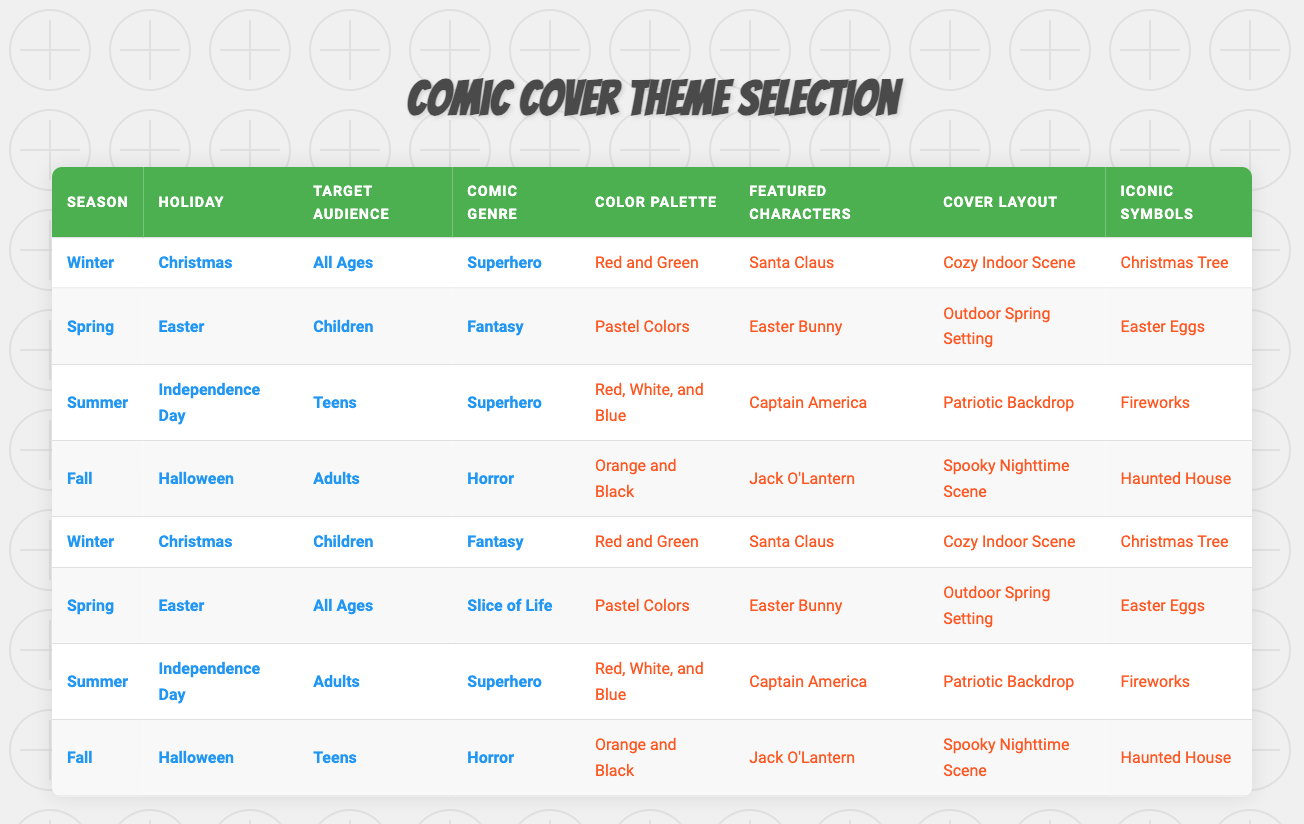What is the color palette for Christmas-themed comic covers targeting children? In the table, I need to look for the row where the Holiday is "Christmas" and Target Audience is "Children." That corresponds to the row that lists the actions: "Red and Green" for the Color Palette.
Answer: Red and Green Which season has the Halloween cover featuring adults in horror genre? I check the table for the row where the Holiday is "Halloween," the Target Audience is "Adults," and the Comic Genre is "Horror." This corresponds to the row with actions: "Orange and Black" for the Color Palette, "Jack O'Lantern" for Featured Characters, "Spooky Nighttime Scene" for Cover Layout, and "Haunted House" for Iconic Symbols.
Answer: Fall Is there a specific comic genre associated with the Easter-themed cover for children? The table indicates that the Easter-themed comic cover targeted at "Children" has a Comic Genre of "Fantasy." Therefore, it is true that a specific genre is associated with it.
Answer: Yes What is the unique combination of featured characters, cover layout, and iconic symbols for the Independence Day comic cover aimed at teens? I look for the row where the Holiday is "Independence Day" and Target Audience is "Teens." This information matches the row with actions: "Captain America" for Featured Characters, "Patriotic Backdrop" for Cover Layout, and "Fireworks" for Iconic Symbols. Combining all these gives us the unique combination for this cover.
Answer: Captain America, Patriotic Backdrop, Fireworks How many cover layouts are associated with Halloween-themed comics? I examine the table to find the rows associated with "Halloween." There are two rows: one for adults with a "Spooky Nighttime Scene" and one for teens that uses the same layout. So, the total number of unique cover layouts for Halloween-themed comics is 1.
Answer: 1 What is the average number of different seasonal-themed comic covers that feature the Easter Bunny? I look in the table for rows associated with the Easter Bunny. There are two rows: one for "Spring" and "All Ages" in the "Slice of Life" genre, and one for "Spring" and "Children" in the "Fantasy" genre. This averages to 2 unique entries for covers featuring the Easter Bunny.
Answer: 2 True or false: The Winter season only features superhero genres for Christmas covers. I check the table and find two rows: one for "All Ages" and "Superhero," and another for "Children" and "Fantasy." Since there are two different genres that include Christmas, the statement is false.
Answer: False What color palette is used for Summer comic covers focusing on Independence Day for adults? I search for the row with both "Summer" and "Independence Day" while noting that the Target Audience is "Adults." This aligns with the Color Palette of "Red, White, and Blue" from the respective row.
Answer: Red, White, and Blue 